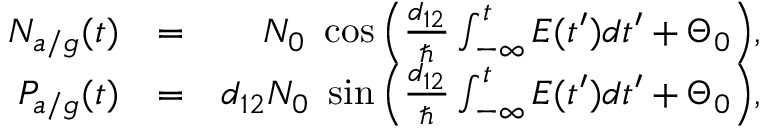Convert formula to latex. <formula><loc_0><loc_0><loc_500><loc_500>\begin{array} { r l r } { N _ { a / g } ( t ) } & { = } & { N _ { 0 } \ \cos \left ( \frac { d _ { 1 2 } } { } \int _ { - \infty } ^ { t } E ( t ^ { \prime } ) d t ^ { \prime } + \Theta _ { 0 } \right ) , } \\ { P _ { a / g } ( t ) } & { = } & { d _ { 1 2 } N _ { 0 } \ \sin \left ( \frac { d _ { 1 2 } } { } \int _ { - \infty } ^ { t } E ( t ^ { \prime } ) d t ^ { \prime } + \Theta _ { 0 } \right ) , } \end{array}</formula> 